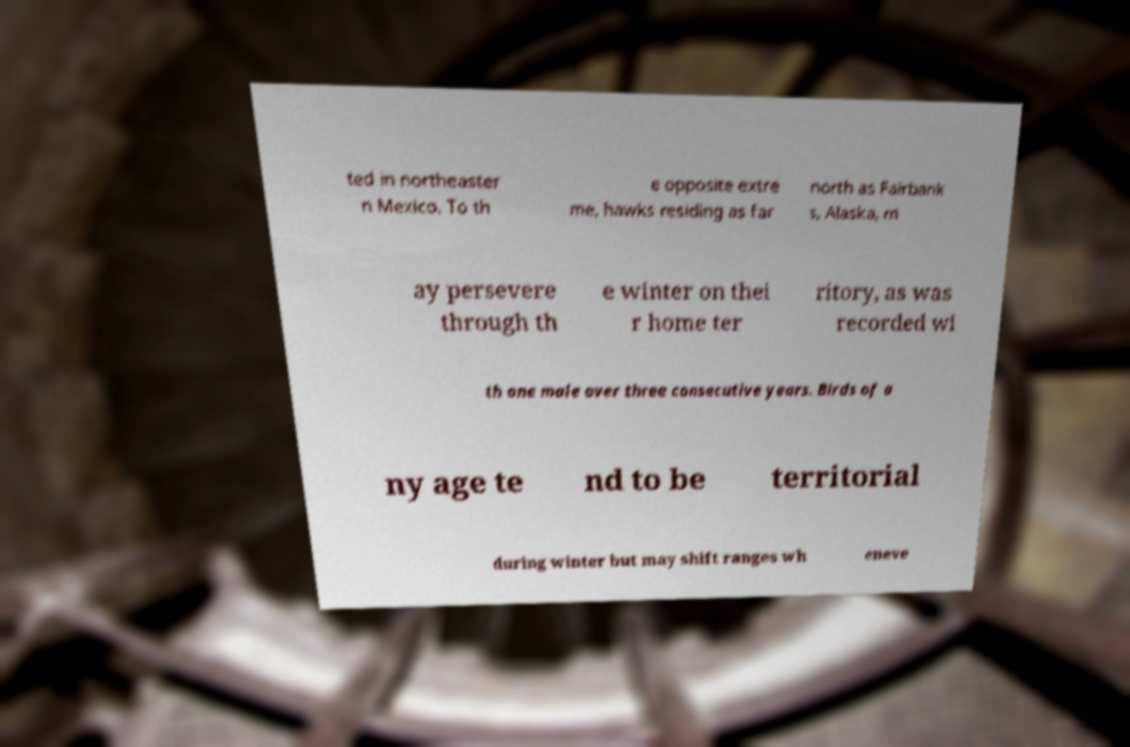Could you extract and type out the text from this image? ted in northeaster n Mexico. To th e opposite extre me, hawks residing as far north as Fairbank s, Alaska, m ay persevere through th e winter on thei r home ter ritory, as was recorded wi th one male over three consecutive years. Birds of a ny age te nd to be territorial during winter but may shift ranges wh eneve 